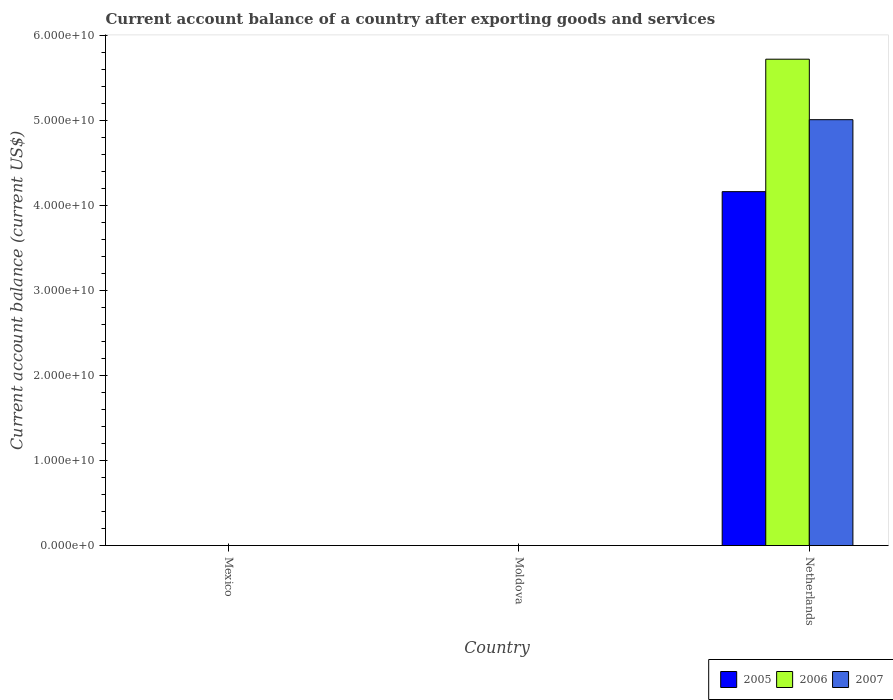How many different coloured bars are there?
Your answer should be compact. 3. Are the number of bars on each tick of the X-axis equal?
Ensure brevity in your answer.  No. In how many cases, is the number of bars for a given country not equal to the number of legend labels?
Make the answer very short. 2. What is the account balance in 2006 in Mexico?
Your answer should be compact. 0. Across all countries, what is the maximum account balance in 2007?
Your answer should be compact. 5.01e+1. Across all countries, what is the minimum account balance in 2006?
Make the answer very short. 0. What is the total account balance in 2005 in the graph?
Provide a succinct answer. 4.16e+1. What is the difference between the account balance in 2005 in Netherlands and the account balance in 2006 in Mexico?
Your answer should be very brief. 4.16e+1. What is the average account balance in 2007 per country?
Provide a succinct answer. 1.67e+1. What is the difference between the account balance of/in 2005 and account balance of/in 2007 in Netherlands?
Keep it short and to the point. -8.46e+09. In how many countries, is the account balance in 2005 greater than 32000000000 US$?
Make the answer very short. 1. What is the difference between the highest and the lowest account balance in 2007?
Your answer should be very brief. 5.01e+1. How many bars are there?
Make the answer very short. 3. Are all the bars in the graph horizontal?
Your response must be concise. No. How many countries are there in the graph?
Offer a terse response. 3. Does the graph contain any zero values?
Provide a short and direct response. Yes. Does the graph contain grids?
Your answer should be compact. No. How many legend labels are there?
Make the answer very short. 3. What is the title of the graph?
Provide a short and direct response. Current account balance of a country after exporting goods and services. What is the label or title of the Y-axis?
Provide a short and direct response. Current account balance (current US$). What is the Current account balance (current US$) of 2007 in Mexico?
Your response must be concise. 0. What is the Current account balance (current US$) in 2005 in Moldova?
Provide a succinct answer. 0. What is the Current account balance (current US$) in 2006 in Moldova?
Ensure brevity in your answer.  0. What is the Current account balance (current US$) in 2007 in Moldova?
Ensure brevity in your answer.  0. What is the Current account balance (current US$) of 2005 in Netherlands?
Ensure brevity in your answer.  4.16e+1. What is the Current account balance (current US$) in 2006 in Netherlands?
Offer a terse response. 5.72e+1. What is the Current account balance (current US$) of 2007 in Netherlands?
Make the answer very short. 5.01e+1. Across all countries, what is the maximum Current account balance (current US$) of 2005?
Make the answer very short. 4.16e+1. Across all countries, what is the maximum Current account balance (current US$) in 2006?
Ensure brevity in your answer.  5.72e+1. Across all countries, what is the maximum Current account balance (current US$) in 2007?
Make the answer very short. 5.01e+1. Across all countries, what is the minimum Current account balance (current US$) of 2007?
Your answer should be very brief. 0. What is the total Current account balance (current US$) of 2005 in the graph?
Your answer should be very brief. 4.16e+1. What is the total Current account balance (current US$) of 2006 in the graph?
Offer a terse response. 5.72e+1. What is the total Current account balance (current US$) of 2007 in the graph?
Make the answer very short. 5.01e+1. What is the average Current account balance (current US$) of 2005 per country?
Offer a terse response. 1.39e+1. What is the average Current account balance (current US$) in 2006 per country?
Offer a very short reply. 1.91e+1. What is the average Current account balance (current US$) of 2007 per country?
Provide a short and direct response. 1.67e+1. What is the difference between the Current account balance (current US$) of 2005 and Current account balance (current US$) of 2006 in Netherlands?
Offer a very short reply. -1.56e+1. What is the difference between the Current account balance (current US$) in 2005 and Current account balance (current US$) in 2007 in Netherlands?
Your response must be concise. -8.46e+09. What is the difference between the Current account balance (current US$) of 2006 and Current account balance (current US$) of 2007 in Netherlands?
Give a very brief answer. 7.11e+09. What is the difference between the highest and the lowest Current account balance (current US$) in 2005?
Provide a succinct answer. 4.16e+1. What is the difference between the highest and the lowest Current account balance (current US$) in 2006?
Provide a short and direct response. 5.72e+1. What is the difference between the highest and the lowest Current account balance (current US$) of 2007?
Give a very brief answer. 5.01e+1. 